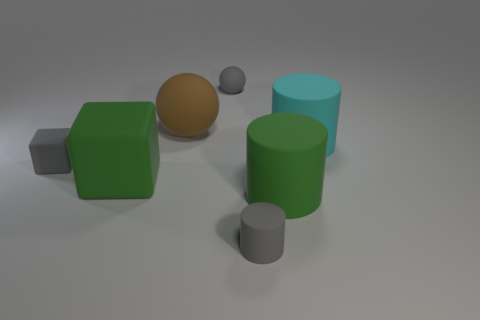Add 3 small blue metal balls. How many objects exist? 10 Subtract all cylinders. How many objects are left? 4 Add 7 small gray things. How many small gray things exist? 10 Subtract 1 green cubes. How many objects are left? 6 Subtract all purple cylinders. Subtract all large things. How many objects are left? 3 Add 5 large green rubber cubes. How many large green rubber cubes are left? 6 